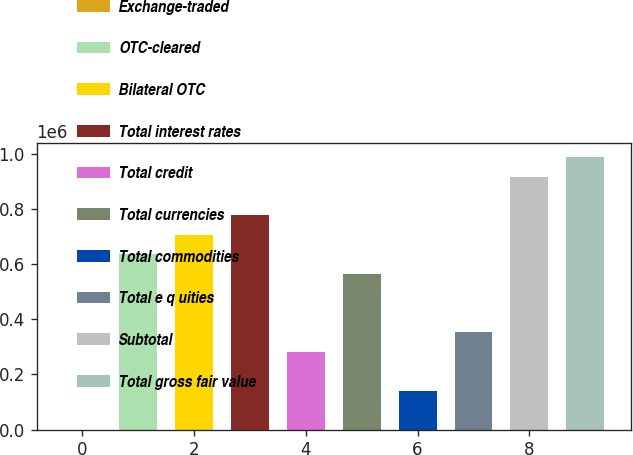Convert chart to OTSL. <chart><loc_0><loc_0><loc_500><loc_500><bar_chart><fcel>Exchange-traded<fcel>OTC-cleared<fcel>Bilateral OTC<fcel>Total interest rates<fcel>Total credit<fcel>Total currencies<fcel>Total commodities<fcel>Total e q uities<fcel>Subtotal<fcel>Total gross fair value<nl><fcel>443<fcel>635659<fcel>706239<fcel>776819<fcel>282761<fcel>565080<fcel>141602<fcel>353341<fcel>917978<fcel>988557<nl></chart> 